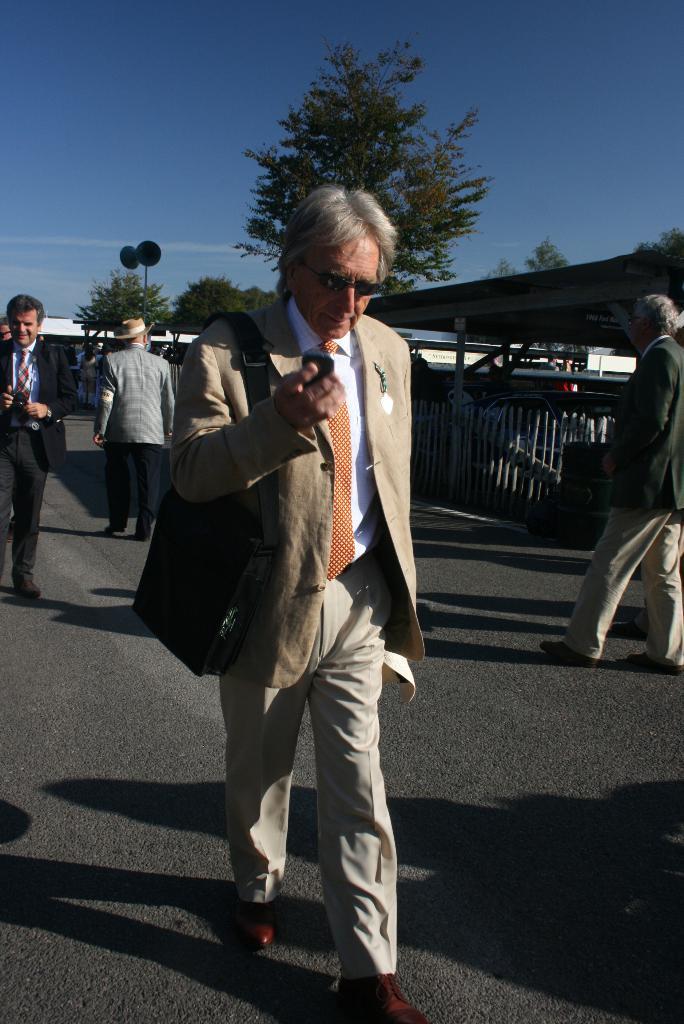Describe this image in one or two sentences. In this picture we can see a group of people walking on the road, fence, shed, trees and in the background we can see the sky with clouds. 